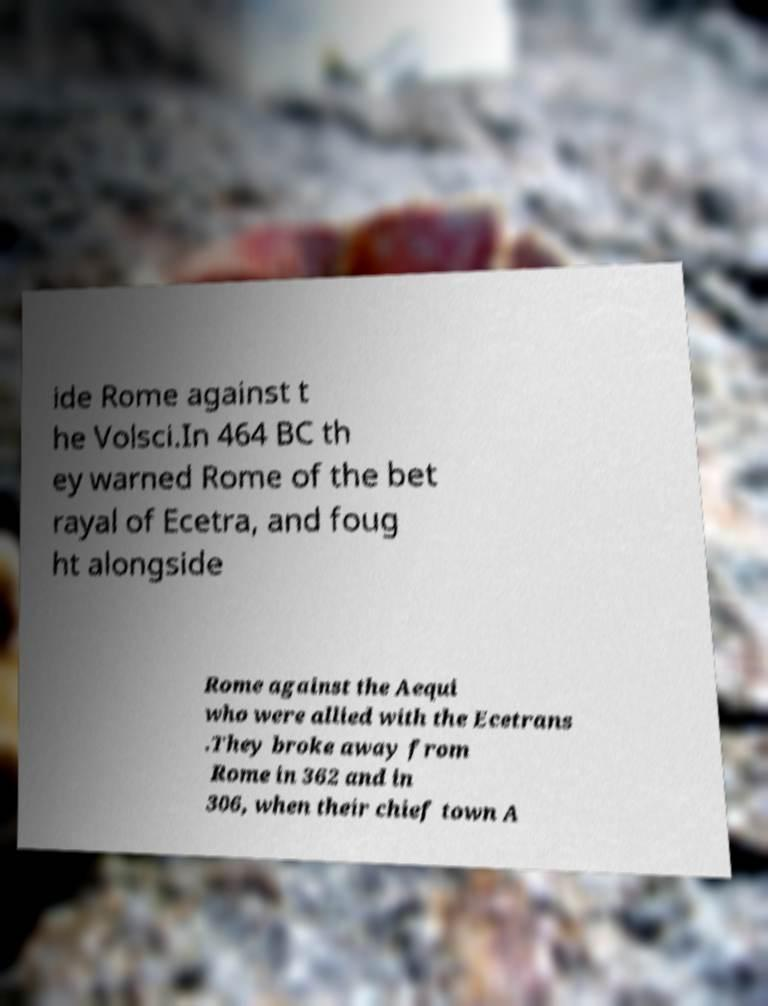Can you accurately transcribe the text from the provided image for me? ide Rome against t he Volsci.In 464 BC th ey warned Rome of the bet rayal of Ecetra, and foug ht alongside Rome against the Aequi who were allied with the Ecetrans .They broke away from Rome in 362 and in 306, when their chief town A 